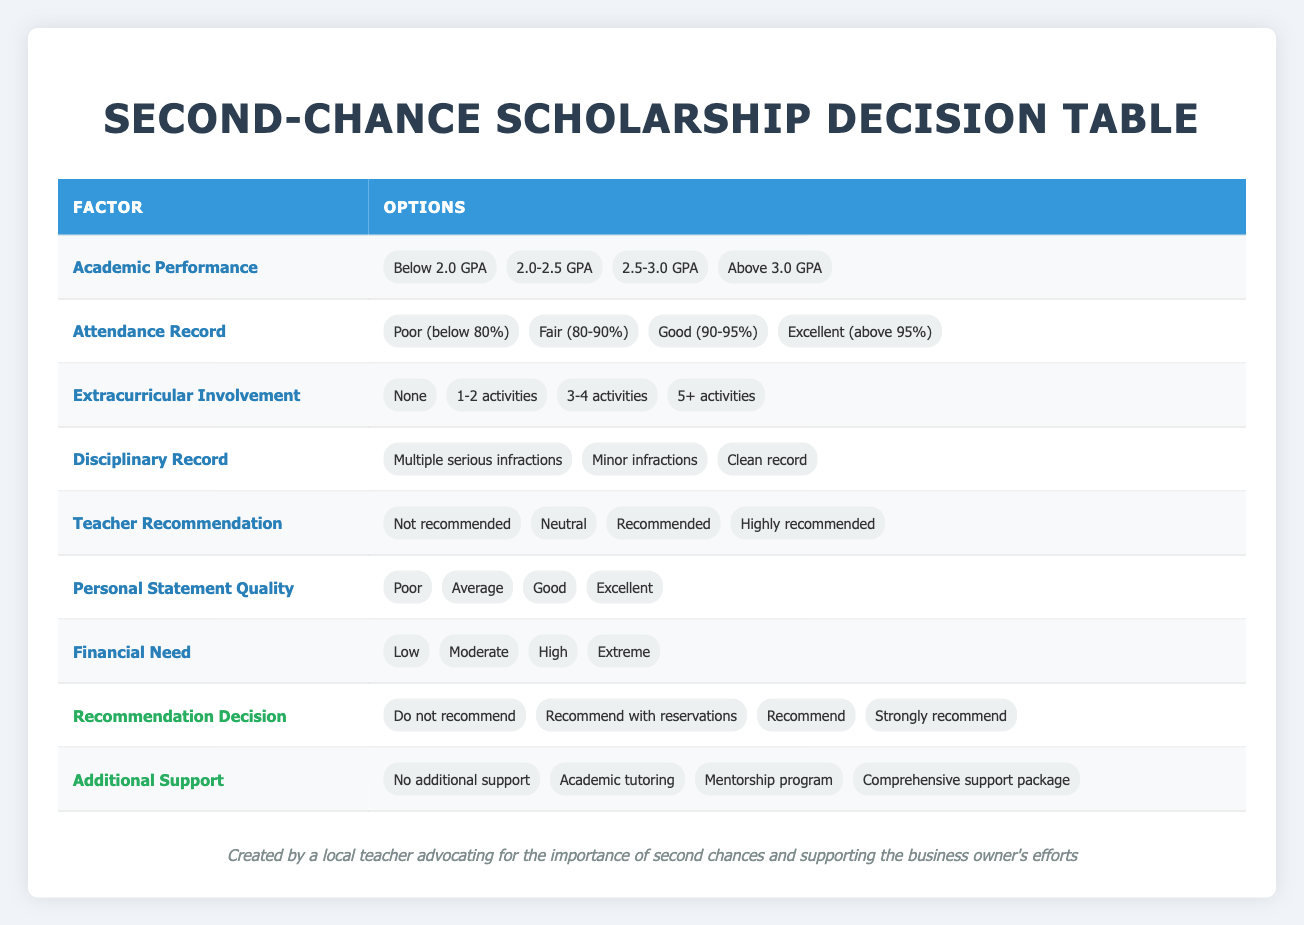What is the highest GPA range listed in the Academic Performance options? The options listed under Academic Performance include Below 2.0 GPA, 2.0-2.5 GPA, 2.5-3.0 GPA, and Above 3.0 GPA. The highest range is Above 3.0 GPA.
Answer: Above 3.0 GPA How many options are there for Attendance Record? The Attendance Record has four options: Poor (below 80%), Fair (80-90%), Good (90-95%), and Excellent (above 95%). Therefore, there are four options.
Answer: Four Is it possible for a student with a "Clean record" in their Disciplinary Record to still be "Not recommended"? In the table's actions, it shows that a "Not recommended" outcome is possible regardless of the Disciplinary Record. Therefore, a student can potentially have a "Clean record" but still receive the "Not recommended" status because other factors like academic performance or teacher recommendation may lead to that decision.
Answer: Yes What is the relationship between "Financial Need" being "Extreme" and the likelihood of receiving a "Strongly recommend"? Generally speaking, an "Extreme" financial need can positively influence a recommendation, but it must be evaluated alongside other factors like academic performance and teacher recommendation. Since the table does not provide explicit logic or data to confirm this positively, it cannot be inferred without further context. Hence, we cannot assume a direct positive relationship between extreme need and a strong recommendation without evaluating the other conditions.
Answer: Cannot determine If a student's Personal Statement Quality is "Excellent" and their Teacher Recommendation is "Highly recommended," what could their Recommendation Decision be? If both the Personal Statement Quality is "Excellent" and the Teacher Recommendation is "Highly recommended," it is reasonable to conclude that their Recommendation Decision could be "Strongly recommend." To be more specific, the combination of high-quality statement and a strong recommendation typically leads to a positive outcome in such tables.
Answer: Strongly recommend 